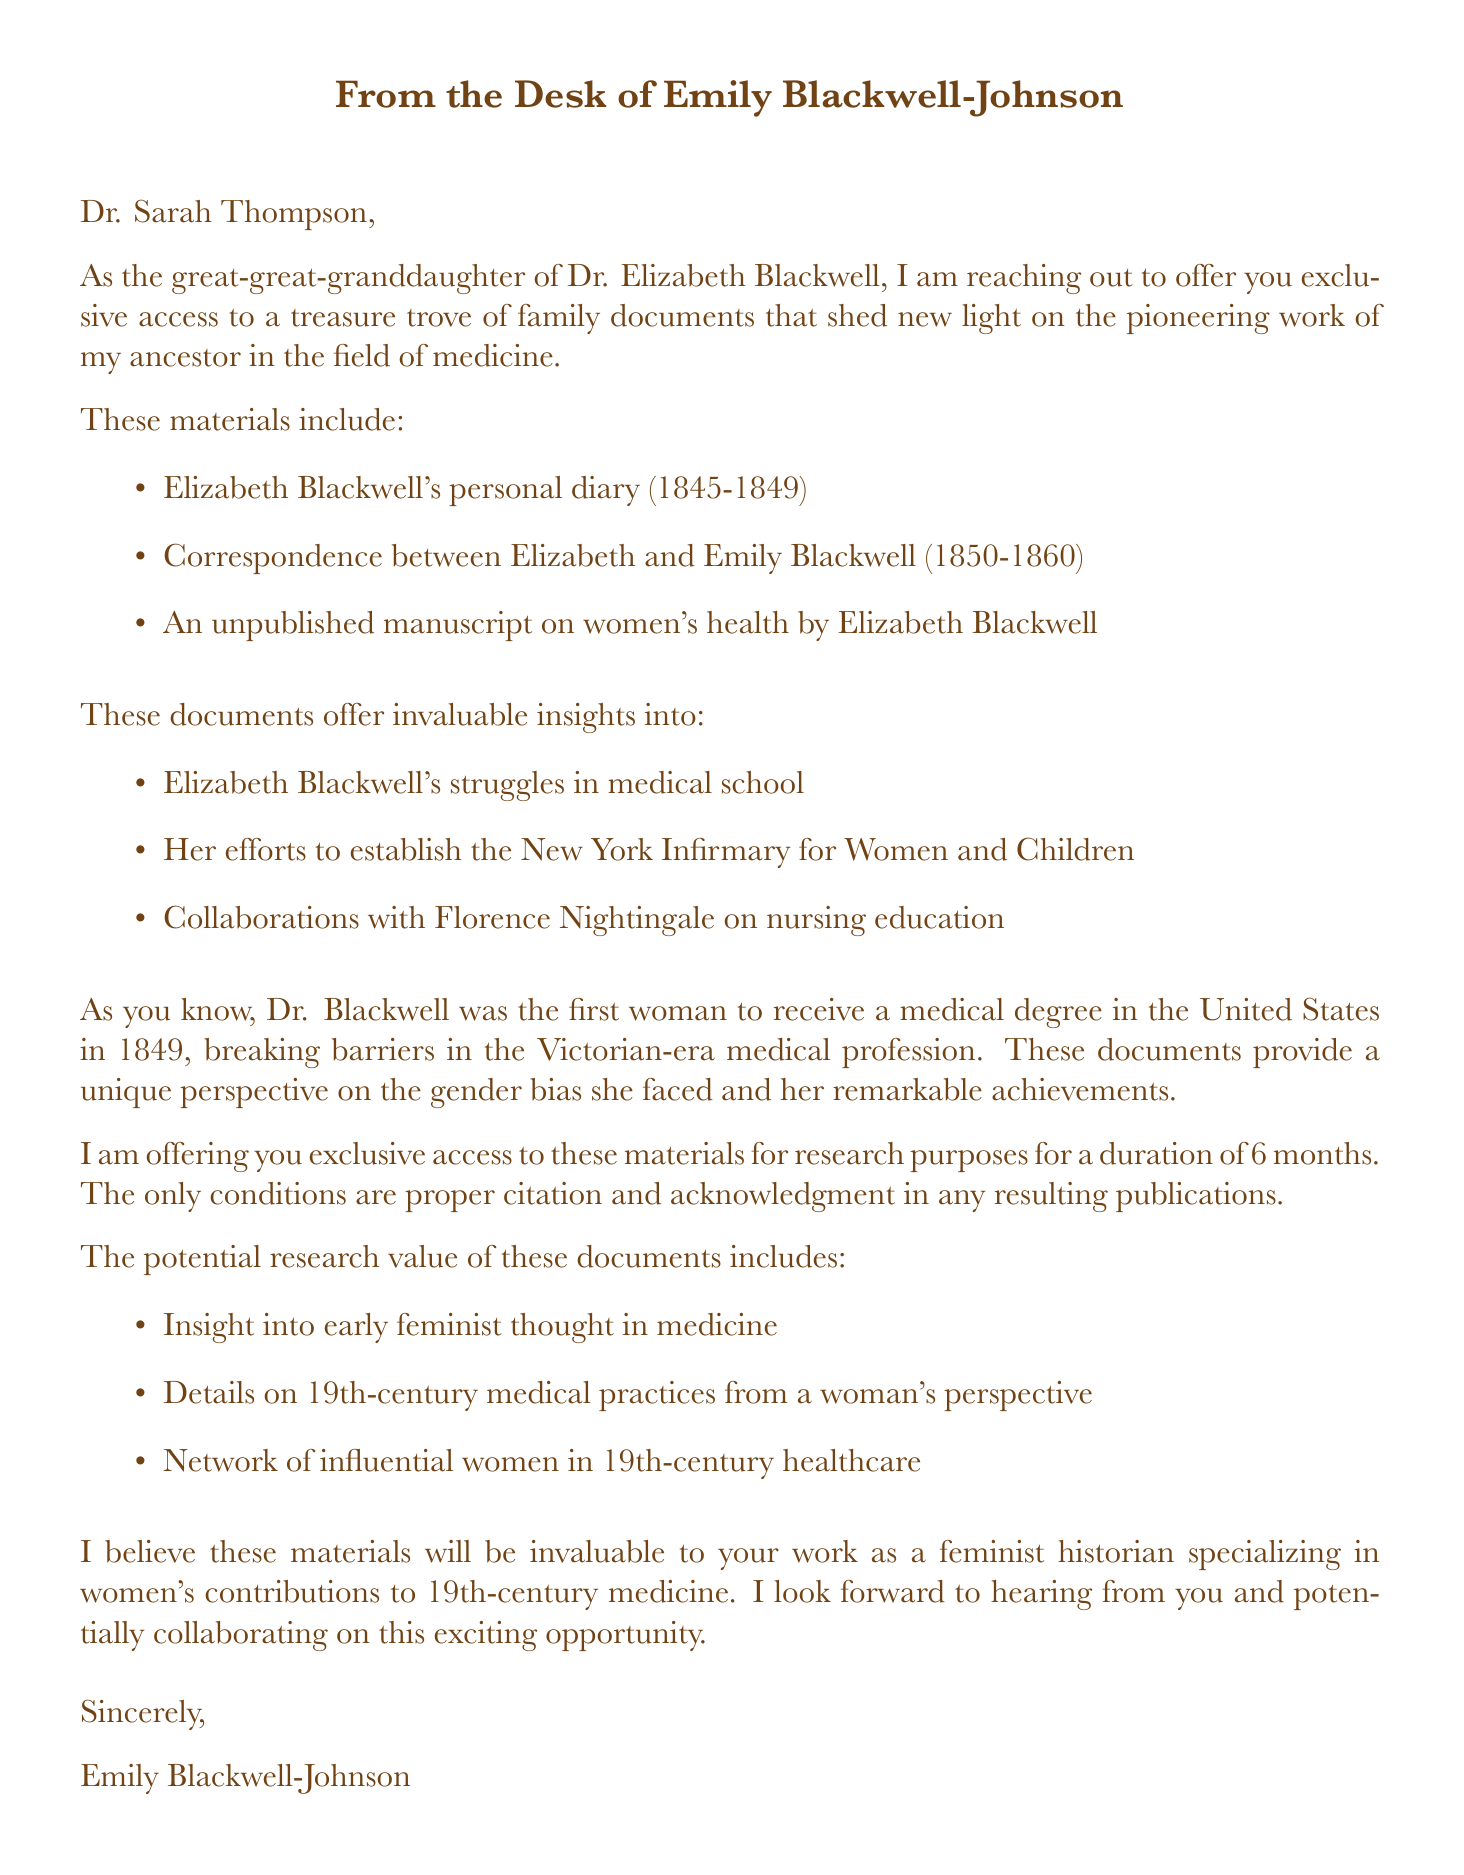what is the name of the sender? The sender's name is stated at the beginning of the letter, which is Emily Blackwell-Johnson.
Answer: Emily Blackwell-Johnson what is the duration of the access being offered? The document specifies that the access is for a duration of 6 months.
Answer: 6 months how many family documents are mentioned? There are three specific family documents listed in the letter.
Answer: Three what is one of the key topics discussed in the documents? The letter mentions several key topics related to Elizabeth Blackwell's contributions and struggles.
Answer: Elizabeth Blackwell's struggles in medical school what notable achievement is attributed to Elizabeth Blackwell? The letter states her notable achievement of being the first woman to receive a medical degree in the United States in 1849.
Answer: First woman to receive a medical degree in the United States (1849) what is a condition for using the documents? The letter outlines a condition that involves proper citation and acknowledgment in any resulting publications.
Answer: Proper citation and acknowledgment what perspective do the documents provide on 19th-century medical practices? The documents are noted to offer a woman's perspective on medical practices of the time.
Answer: A woman's perspective who is mentioned as a collaborator with Elizabeth Blackwell? The letter references a significant collaboration with Florence Nightingale regarding nursing education.
Answer: Florence Nightingale 